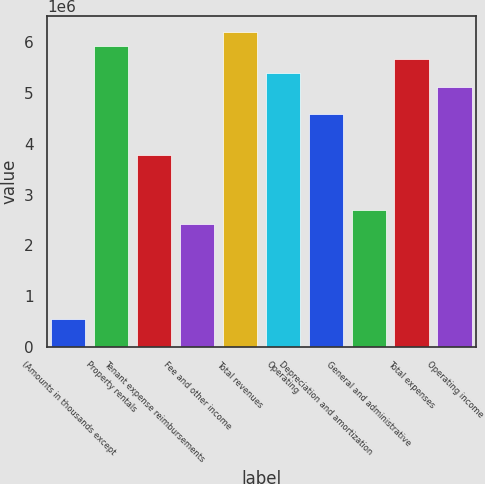Convert chart to OTSL. <chart><loc_0><loc_0><loc_500><loc_500><bar_chart><fcel>(Amounts in thousands except<fcel>Property rentals<fcel>Tenant expense reimbursements<fcel>Fee and other income<fcel>Total revenues<fcel>Operating<fcel>Depreciation and amortization<fcel>General and administrative<fcel>Total expenses<fcel>Operating income<nl><fcel>539411<fcel>5.93351e+06<fcel>3.77587e+06<fcel>2.42735e+06<fcel>6.20322e+06<fcel>5.3941e+06<fcel>4.58499e+06<fcel>2.69705e+06<fcel>5.66381e+06<fcel>5.1244e+06<nl></chart> 